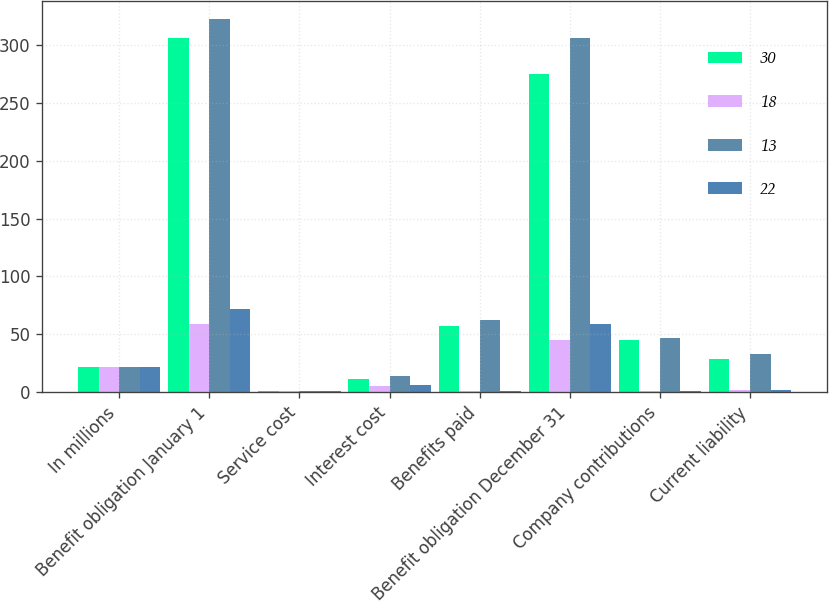<chart> <loc_0><loc_0><loc_500><loc_500><stacked_bar_chart><ecel><fcel>In millions<fcel>Benefit obligation January 1<fcel>Service cost<fcel>Interest cost<fcel>Benefits paid<fcel>Benefit obligation December 31<fcel>Company contributions<fcel>Current liability<nl><fcel>30<fcel>21.5<fcel>306<fcel>1<fcel>11<fcel>57<fcel>275<fcel>45<fcel>29<nl><fcel>18<fcel>21.5<fcel>59<fcel>1<fcel>5<fcel>1<fcel>45<fcel>1<fcel>2<nl><fcel>13<fcel>21.5<fcel>322<fcel>1<fcel>14<fcel>62<fcel>306<fcel>47<fcel>33<nl><fcel>22<fcel>21.5<fcel>72<fcel>1<fcel>6<fcel>1<fcel>59<fcel>1<fcel>2<nl></chart> 